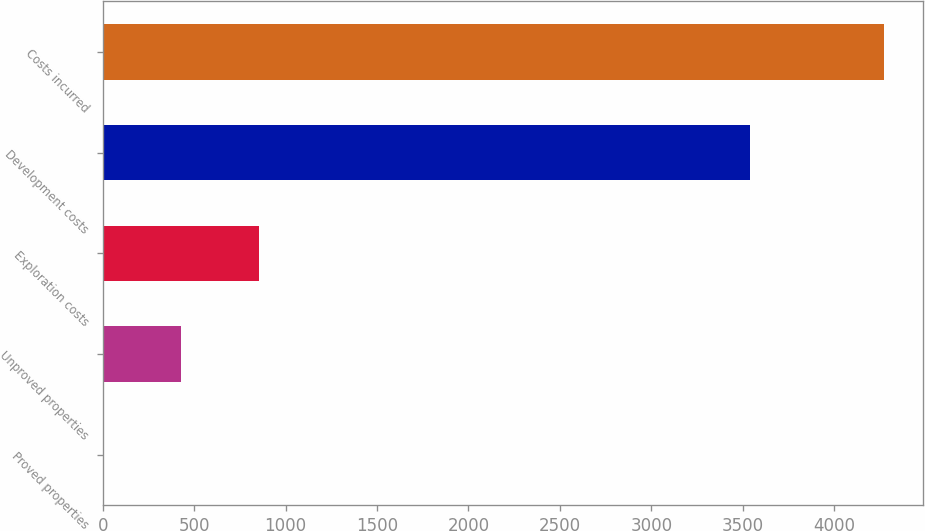Convert chart to OTSL. <chart><loc_0><loc_0><loc_500><loc_500><bar_chart><fcel>Proved properties<fcel>Unproved properties<fcel>Exploration costs<fcel>Development costs<fcel>Costs incurred<nl><fcel>3<fcel>429.7<fcel>856.4<fcel>3542<fcel>4270<nl></chart> 